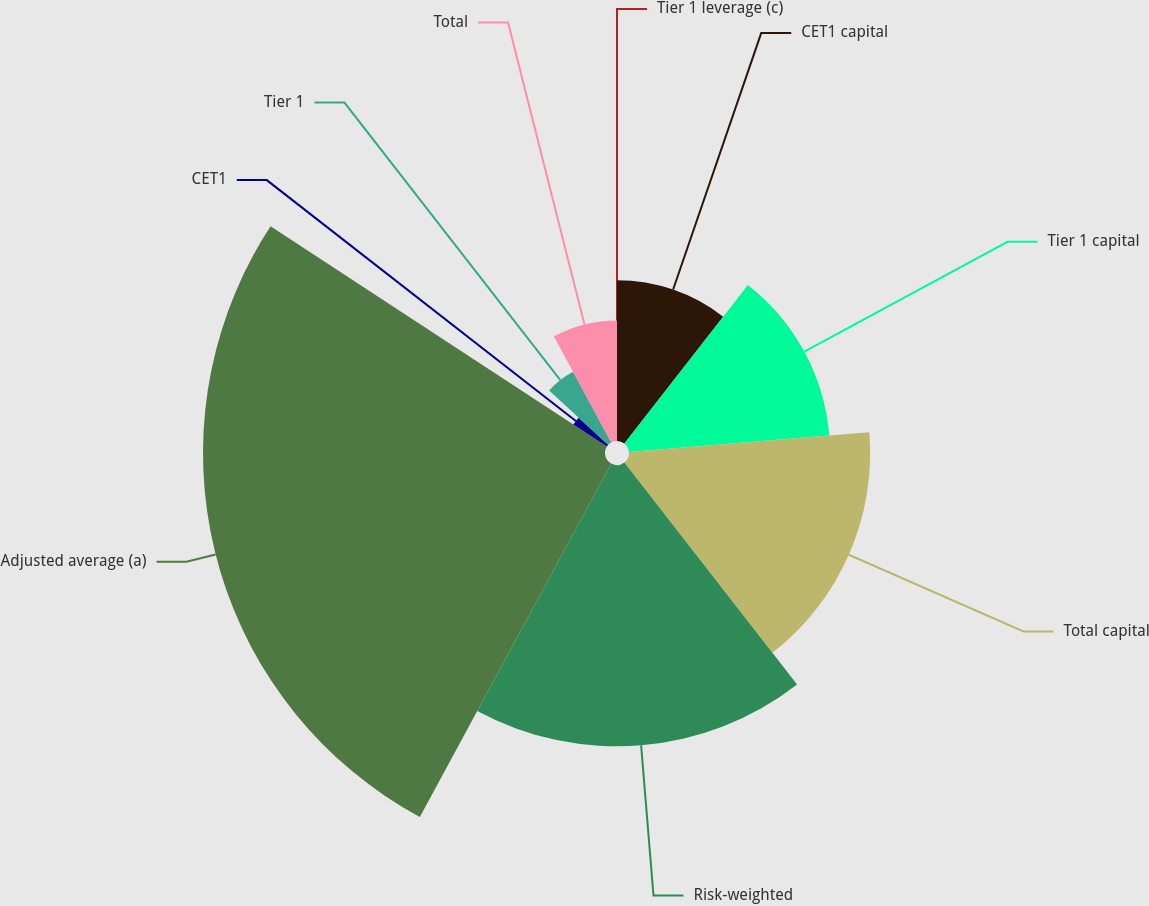Convert chart to OTSL. <chart><loc_0><loc_0><loc_500><loc_500><pie_chart><fcel>CET1 capital<fcel>Tier 1 capital<fcel>Total capital<fcel>Risk-weighted<fcel>Adjusted average (a)<fcel>CET1<fcel>Tier 1<fcel>Total<fcel>Tier 1 leverage (c)<nl><fcel>10.53%<fcel>13.16%<fcel>15.79%<fcel>18.42%<fcel>26.32%<fcel>2.63%<fcel>5.26%<fcel>7.89%<fcel>0.0%<nl></chart> 